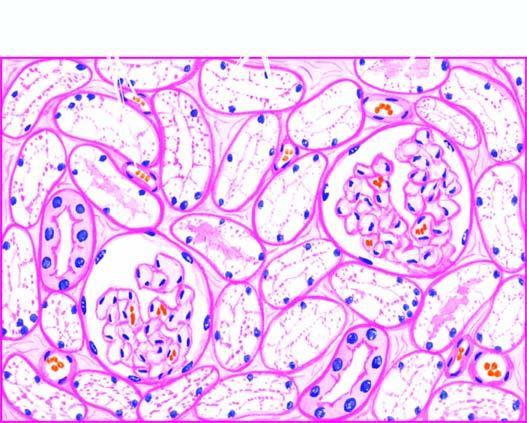what are distended with cytoplasmic vacuoles while the interstitial vasculature is compressed?
Answer the question using a single word or phrase. Tubular epithelial cells is compressed 